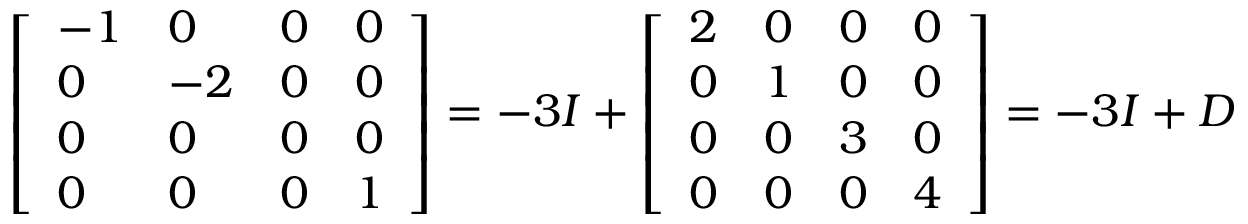Convert formula to latex. <formula><loc_0><loc_0><loc_500><loc_500>\left [ \begin{array} { l l l l } { - 1 } & { 0 } & { 0 } & { 0 } \\ { 0 } & { - 2 } & { 0 } & { 0 } \\ { 0 } & { 0 } & { 0 } & { 0 } \\ { 0 } & { 0 } & { 0 } & { 1 } \end{array} \right ] = - 3 I + \left [ \begin{array} { l l l l } { 2 } & { 0 } & { 0 } & { 0 } \\ { 0 } & { 1 } & { 0 } & { 0 } \\ { 0 } & { 0 } & { 3 } & { 0 } \\ { 0 } & { 0 } & { 0 } & { 4 } \end{array} \right ] = - 3 I + D</formula> 